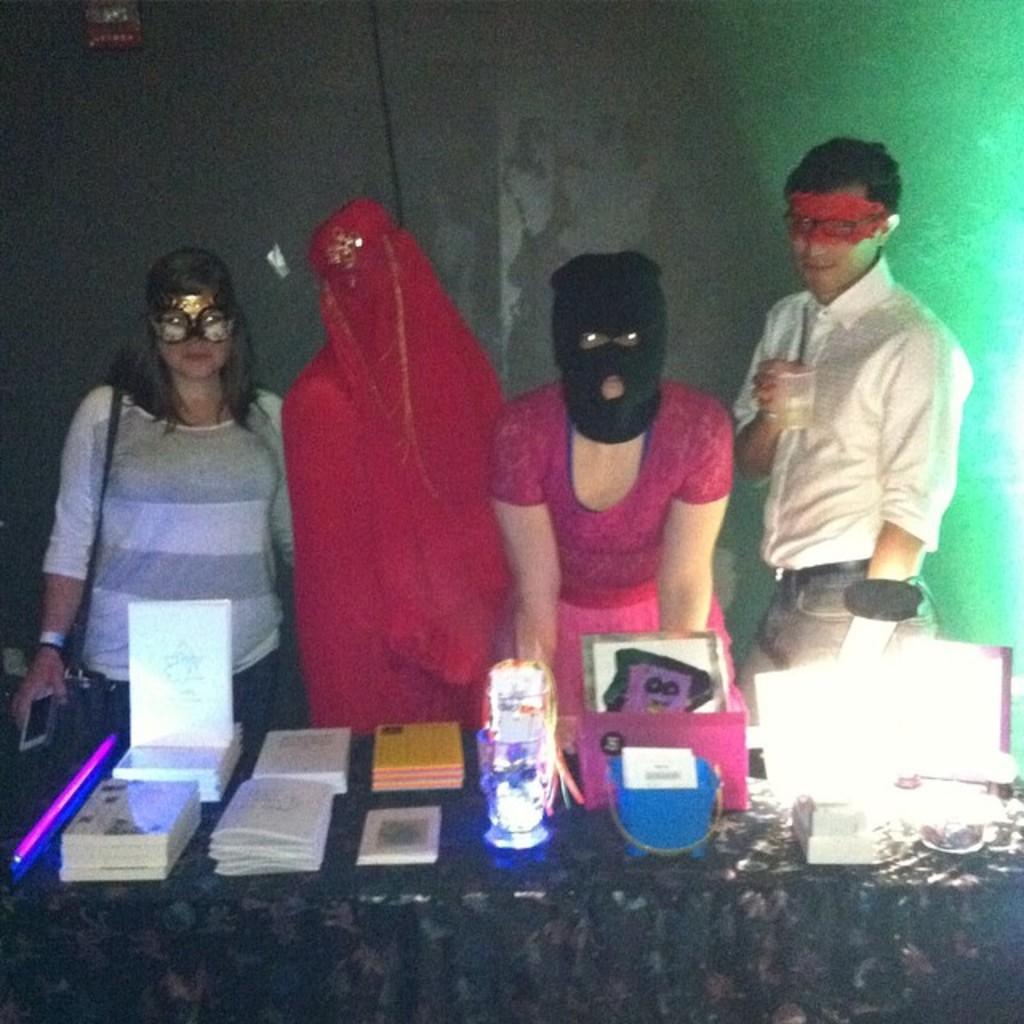Please provide a concise description of this image. In this image we can see one table covered with table cloth, one wall in the background, three objects attached to the wall, four people are standing near the table, one man holding a glass with liquid on the right side of the image, one person in a red costume, three people wearing masks, one person with black mask touching the table, one woman wearing a bag and holding a cell phone on the left side of the image. There are some books and some objects on the table. 